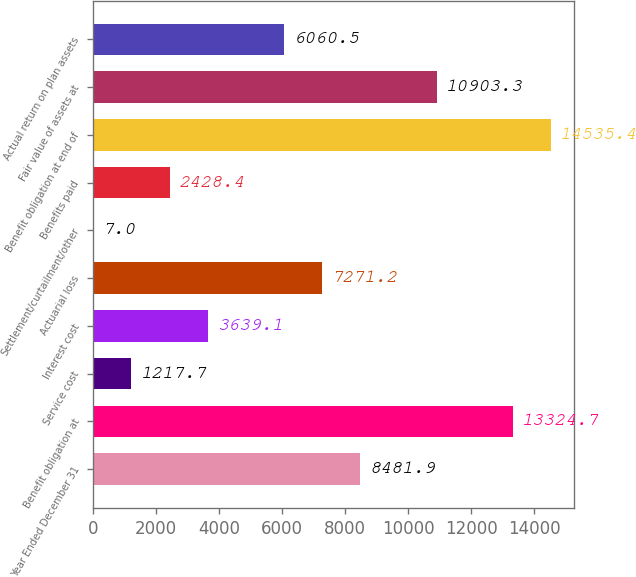Convert chart to OTSL. <chart><loc_0><loc_0><loc_500><loc_500><bar_chart><fcel>Year Ended December 31<fcel>Benefit obligation at<fcel>Service cost<fcel>Interest cost<fcel>Actuarial loss<fcel>Settlement/curtailment/other<fcel>Benefits paid<fcel>Benefit obligation at end of<fcel>Fair value of assets at<fcel>Actual return on plan assets<nl><fcel>8481.9<fcel>13324.7<fcel>1217.7<fcel>3639.1<fcel>7271.2<fcel>7<fcel>2428.4<fcel>14535.4<fcel>10903.3<fcel>6060.5<nl></chart> 